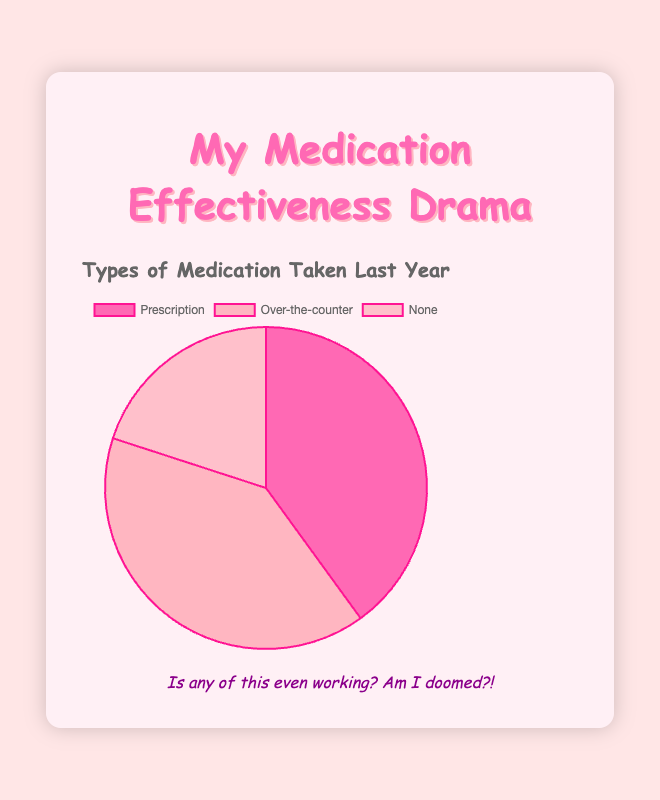What are the three categories of medication usage shown in the pie chart? The pie chart has three slices labeled as ‘Prescription’, ‘Over-the-counter’, and ‘None’.
Answer: Prescription, Over-the-counter, None What is the largest category of medication usage? By looking at the slices, the 'Prescription' and 'Over-the-counter' categories appear larger than the 'None' category.
Answer: Prescription Which color represents the ‘None’ category in the pie chart? The ‘None’ category is represented by the lightest pink color in the pie chart.
Answer: Light pink How many types of medications are taken under the ‘Prescription’ category? The legend or details indicate that there are three medications listed under the ‘Prescription’ category.
Answer: 3 Compare the perceived effectiveness of medications in the ‘Prescription’ category. Which one has the lowest perceived effectiveness? The perceived effectiveness for ‘Amoxicillin’ is moderate, ‘Lisinopril’ is high, and ‘Fluoxetine’ is low. Thus, ‘Fluoxetine’ has the lowest perceived effectiveness.
Answer: Fluoxetine Out of the categories listed, which one has no medications taken? The ‘None’ category by definition has no medications listed under it.
Answer: None What percentage of the total medication usage is represented by the ‘Over-the-counter’ category? The pie chart shows that the ‘Over-the-counter’ category accounts for 2 out of the 5 total data points. The percentage is therefore (2/5)*100 = 40%.
Answer: 40% Which category has an equal number of medications compared to the ‘Prescription’ category? Both the ‘Prescription’ and ‘Over-the-counter’ categories have 3 medications each.
Answer: Over-the-counter How many categories represent at least one type of medication taken? Both ‘Prescription’ and ‘Over-the-counter’ categories have medications listed, making a total of 2 categories with at least one medication.
Answer: 2 